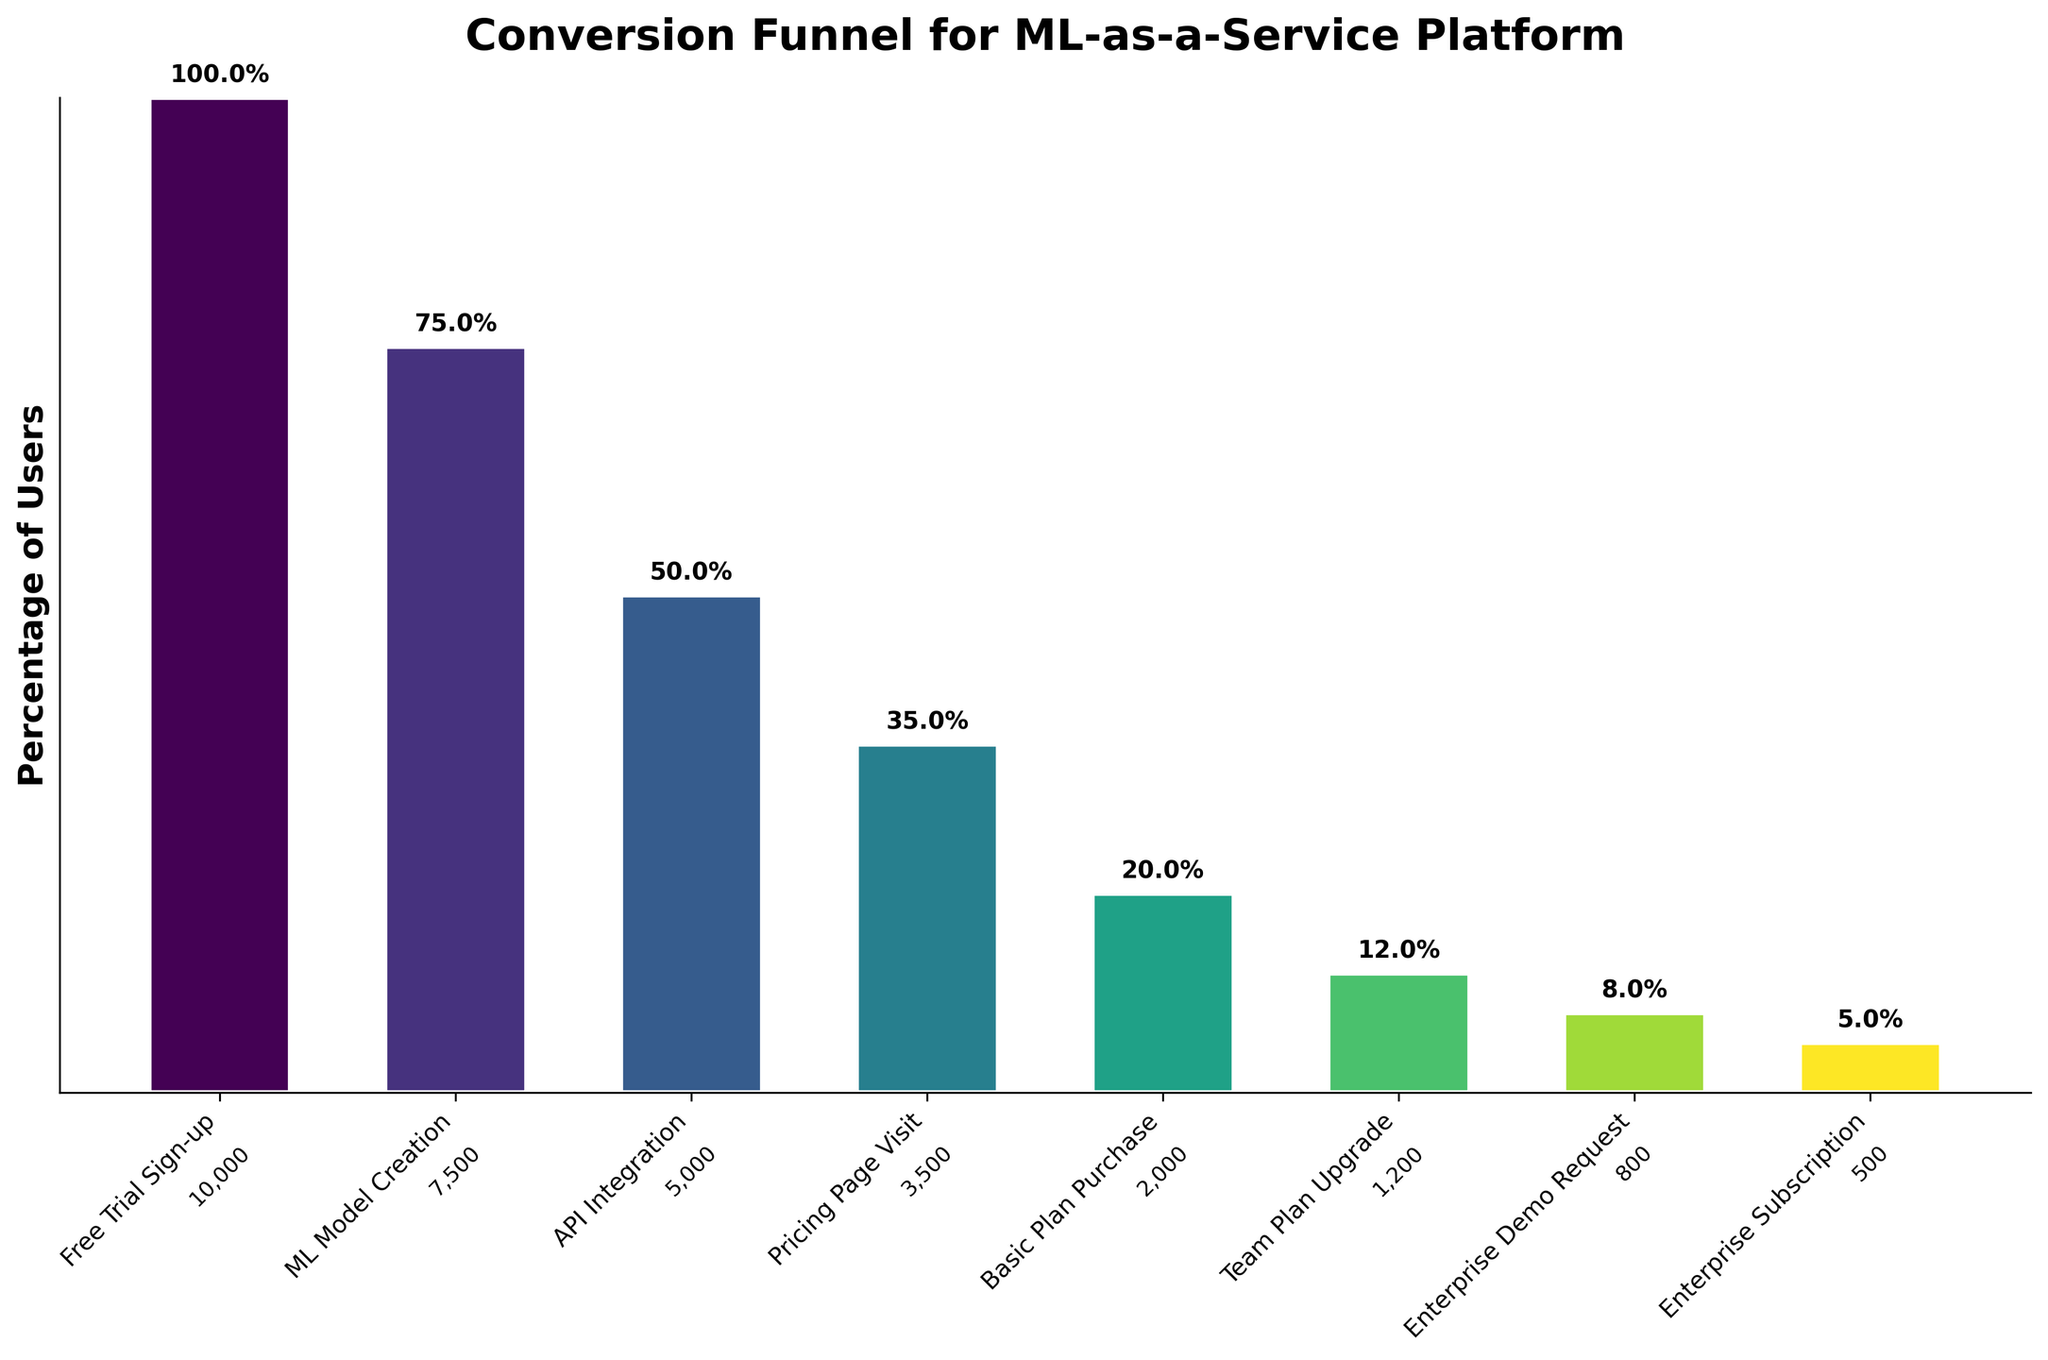what is the title of the funnel chart The title is located at the top center of the chart and usually provides a summary of what the chart represents. Here, the title "Conversion Funnel for ML-as-a-Service Platform" is clearly displayed.
Answer: Conversion Funnel for ML-as-a-Service Platform What is the percentage of users who signed up for the free trial? The first bar represents the "Free Trial Sign-up" stage. According to the percentage label above this bar, the percentage is seen to be 100.0%.
Answer: 100.0% Which stage has the lowest number of users? By looking at the height of the bars and the number of users below each bar, we see that the "Enterprise Subscription" stage has the lowest number of users, with 500 users.
Answer: Enterprise Subscription How many users visited the Pricing Page? The specific value for each stage is given below each bar label. The "Pricing Page Visit" stage has 3,500 users.
Answer: 3,500 What percentage of users requested an Enterprise Demo? The percentage value above the "Enterprise Demo Request" bar indicates the value. It shows 8.0%.
Answer: 8.0% How many users dropped off between the Free Trial Sign-up and the ML Model Creation stages? We subtract the users in the "ML Model Creation" stage (7,500) from the "Free Trial Sign-up" stage (10,000). This gives us 10,000 - 7,500.
Answer: 2,500 What is the percentage drop from team plan upgrade to enterprise subscription? The percentage for the "Team Plan Upgrade" is 12.0% and for the "Enterprise Subscription" is 5.0%. The drop is calculated as 12.0% - 5.0%.
Answer: 7.0% What is the percentage increase in user retention between API Integration and Pricing Page Visit? We look at the percentages above each bar: 50.0% for "API Integration" and 35.0% for "Pricing Page Visit." This represents a decrease, calculated as 50.0% - 35.0%.
Answer: 15.0% What stage has the highest dropout rate in terms of percentage? The dropout rate can be deduced by comparing percentage values between consecutive stages. The highest drop seems to be from "ML Model Creation" (75.0%) to "API Integration" (50.0%), which amounts to a 25.0% drop.
Answer: From ML Model Creation to API Integration How many users upgraded from the Basic Plan Purchase to the Team Plan Upgrade? The "Basic Plan Purchase" has 2,000 users, and the "Team Plan Upgrade" has 1,200 users. The difference is obtained by 2,000 - 1,200.
Answer: 800 